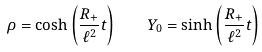<formula> <loc_0><loc_0><loc_500><loc_500>\rho = \cosh \left ( \frac { R _ { + } } { \ell ^ { 2 } } t \right ) \quad Y _ { 0 } = \sinh \left ( \frac { R _ { + } } { \ell ^ { 2 } } t \right )</formula> 